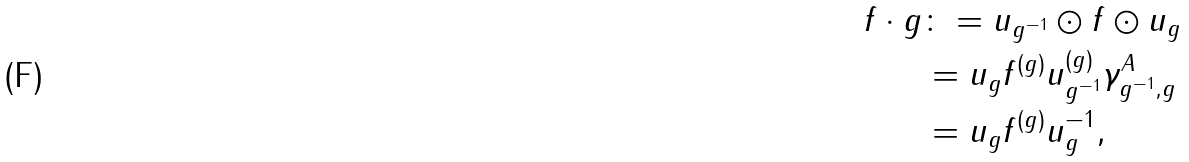Convert formula to latex. <formula><loc_0><loc_0><loc_500><loc_500>f \cdot g & \colon = u _ { g ^ { - 1 } } \odot f \odot u _ { g } \\ & = u _ { g } f ^ { ( g ) } u _ { g ^ { - 1 } } ^ { ( g ) } \gamma _ { g ^ { - 1 } , g } ^ { A } \\ & = u _ { g } f ^ { ( g ) } u _ { g } ^ { - 1 } ,</formula> 